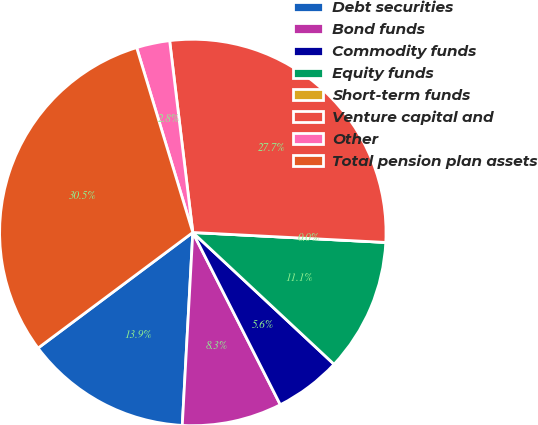Convert chart to OTSL. <chart><loc_0><loc_0><loc_500><loc_500><pie_chart><fcel>Debt securities<fcel>Bond funds<fcel>Commodity funds<fcel>Equity funds<fcel>Short-term funds<fcel>Venture capital and<fcel>Other<fcel>Total pension plan assets<nl><fcel>13.92%<fcel>8.35%<fcel>5.57%<fcel>11.13%<fcel>0.0%<fcel>27.74%<fcel>2.78%<fcel>30.52%<nl></chart> 